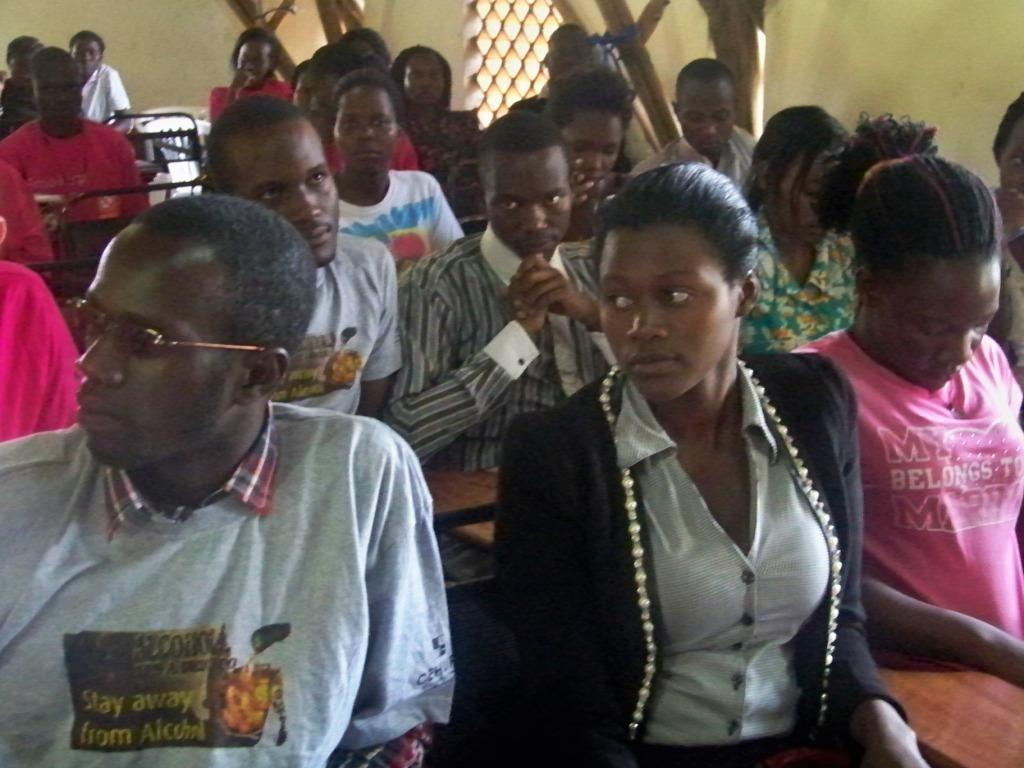What is present in the image that serves as a barrier or divider? There is a wall in the image. What are the people in the image doing? The people in the image are sitting on benches. What type of coat is hanging on the wall in the image? There is no coat present in the image; only a wall and people sitting on benches are visible. How many lizards can be seen crawling on the benches in the image? There are no lizards present in the image; only people sitting on benches are visible. 